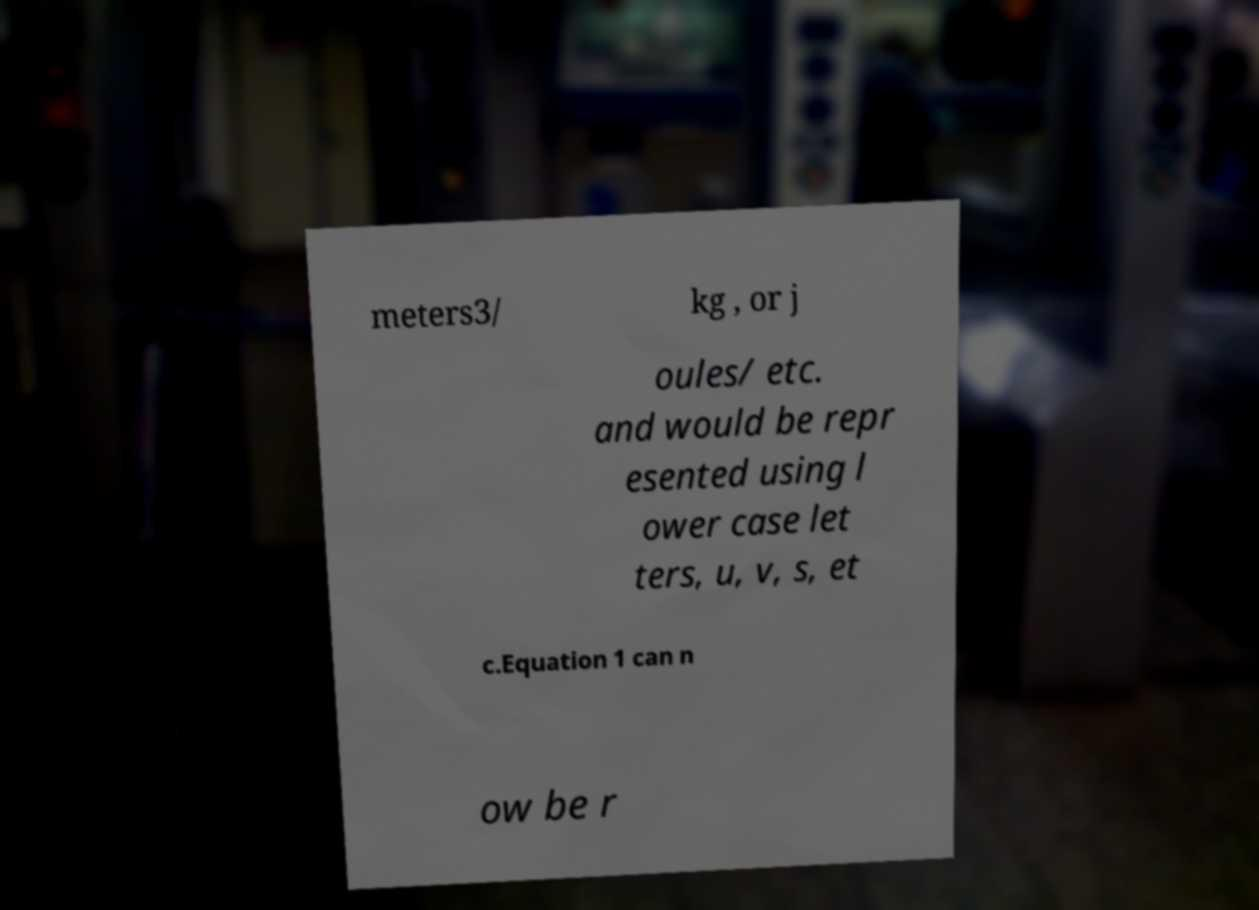Please identify and transcribe the text found in this image. meters3/ kg , or j oules/ etc. and would be repr esented using l ower case let ters, u, v, s, et c.Equation 1 can n ow be r 